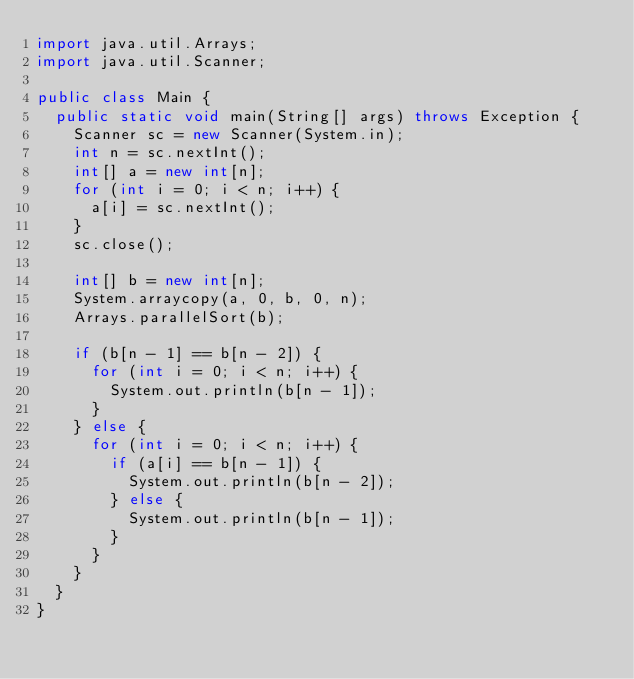<code> <loc_0><loc_0><loc_500><loc_500><_Java_>import java.util.Arrays;
import java.util.Scanner;

public class Main {
	public static void main(String[] args) throws Exception {
		Scanner sc = new Scanner(System.in);
		int n = sc.nextInt();
		int[] a = new int[n];
		for (int i = 0; i < n; i++) {
			a[i] = sc.nextInt();
		}
		sc.close();

		int[] b = new int[n];
		System.arraycopy(a, 0, b, 0, n);
		Arrays.parallelSort(b);

		if (b[n - 1] == b[n - 2]) {
			for (int i = 0; i < n; i++) {
				System.out.println(b[n - 1]);
			}
		} else {
			for (int i = 0; i < n; i++) {
				if (a[i] == b[n - 1]) {
					System.out.println(b[n - 2]);
				} else {
					System.out.println(b[n - 1]);
				}
			}
		}
	}
}
</code> 